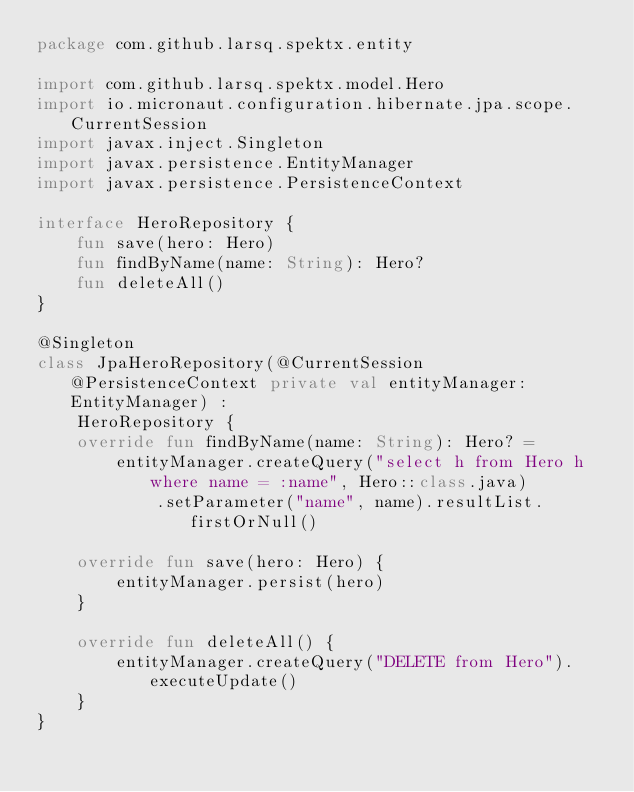Convert code to text. <code><loc_0><loc_0><loc_500><loc_500><_Kotlin_>package com.github.larsq.spektx.entity

import com.github.larsq.spektx.model.Hero
import io.micronaut.configuration.hibernate.jpa.scope.CurrentSession
import javax.inject.Singleton
import javax.persistence.EntityManager
import javax.persistence.PersistenceContext

interface HeroRepository {
    fun save(hero: Hero)
    fun findByName(name: String): Hero?
    fun deleteAll()
}

@Singleton
class JpaHeroRepository(@CurrentSession @PersistenceContext private val entityManager: EntityManager) :
    HeroRepository {
    override fun findByName(name: String): Hero? =
        entityManager.createQuery("select h from Hero h where name = :name", Hero::class.java)
            .setParameter("name", name).resultList.firstOrNull()

    override fun save(hero: Hero) {
        entityManager.persist(hero)
    }

    override fun deleteAll() {
        entityManager.createQuery("DELETE from Hero").executeUpdate()
    }
}</code> 